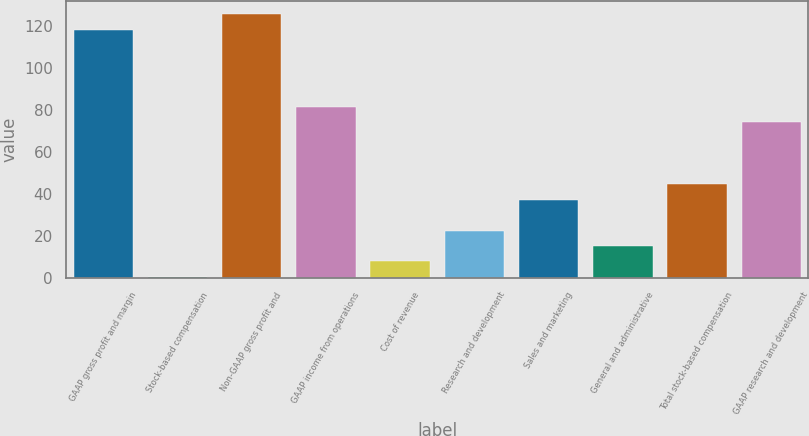Convert chart. <chart><loc_0><loc_0><loc_500><loc_500><bar_chart><fcel>GAAP gross profit and margin<fcel>Stock-based compensation<fcel>Non-GAAP gross profit and<fcel>GAAP income from operations<fcel>Cost of revenue<fcel>Research and development<fcel>Sales and marketing<fcel>General and administrative<fcel>Total stock-based compensation<fcel>GAAP research and development<nl><fcel>118.38<fcel>0.3<fcel>125.76<fcel>81.48<fcel>7.68<fcel>22.44<fcel>37.2<fcel>15.06<fcel>44.58<fcel>74.1<nl></chart> 